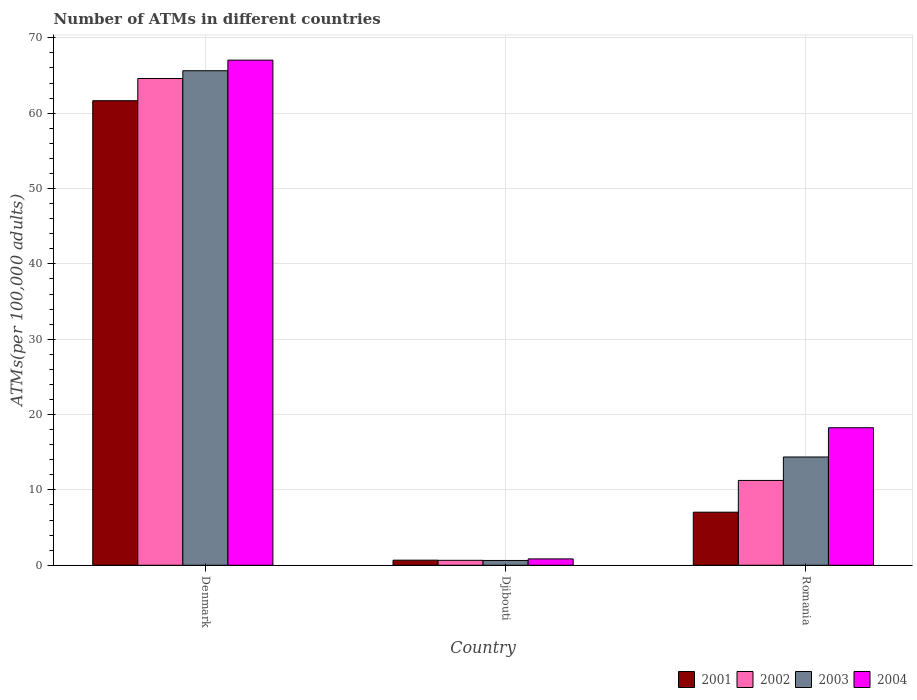How many different coloured bars are there?
Ensure brevity in your answer.  4. How many groups of bars are there?
Give a very brief answer. 3. Are the number of bars per tick equal to the number of legend labels?
Offer a terse response. Yes. Are the number of bars on each tick of the X-axis equal?
Your answer should be very brief. Yes. How many bars are there on the 2nd tick from the left?
Provide a succinct answer. 4. What is the label of the 2nd group of bars from the left?
Your answer should be very brief. Djibouti. In how many cases, is the number of bars for a given country not equal to the number of legend labels?
Your answer should be very brief. 0. What is the number of ATMs in 2002 in Romania?
Provide a short and direct response. 11.26. Across all countries, what is the maximum number of ATMs in 2001?
Your response must be concise. 61.66. Across all countries, what is the minimum number of ATMs in 2004?
Keep it short and to the point. 0.84. In which country was the number of ATMs in 2004 maximum?
Make the answer very short. Denmark. In which country was the number of ATMs in 2004 minimum?
Offer a very short reply. Djibouti. What is the total number of ATMs in 2003 in the graph?
Ensure brevity in your answer.  80.65. What is the difference between the number of ATMs in 2003 in Denmark and that in Djibouti?
Your answer should be very brief. 65. What is the difference between the number of ATMs in 2003 in Romania and the number of ATMs in 2002 in Denmark?
Provide a short and direct response. -50.24. What is the average number of ATMs in 2002 per country?
Make the answer very short. 25.51. What is the difference between the number of ATMs of/in 2002 and number of ATMs of/in 2001 in Denmark?
Offer a terse response. 2.95. What is the ratio of the number of ATMs in 2003 in Denmark to that in Romania?
Ensure brevity in your answer.  4.57. Is the number of ATMs in 2004 in Denmark less than that in Romania?
Provide a short and direct response. No. Is the difference between the number of ATMs in 2002 in Denmark and Romania greater than the difference between the number of ATMs in 2001 in Denmark and Romania?
Provide a short and direct response. No. What is the difference between the highest and the second highest number of ATMs in 2003?
Make the answer very short. -65. What is the difference between the highest and the lowest number of ATMs in 2002?
Ensure brevity in your answer.  63.95. In how many countries, is the number of ATMs in 2002 greater than the average number of ATMs in 2002 taken over all countries?
Give a very brief answer. 1. Is the sum of the number of ATMs in 2003 in Denmark and Romania greater than the maximum number of ATMs in 2004 across all countries?
Your answer should be compact. Yes. What does the 4th bar from the left in Djibouti represents?
Ensure brevity in your answer.  2004. Is it the case that in every country, the sum of the number of ATMs in 2001 and number of ATMs in 2003 is greater than the number of ATMs in 2004?
Offer a very short reply. Yes. What is the difference between two consecutive major ticks on the Y-axis?
Provide a succinct answer. 10. Are the values on the major ticks of Y-axis written in scientific E-notation?
Ensure brevity in your answer.  No. Does the graph contain any zero values?
Your answer should be very brief. No. Where does the legend appear in the graph?
Ensure brevity in your answer.  Bottom right. How are the legend labels stacked?
Provide a succinct answer. Horizontal. What is the title of the graph?
Provide a short and direct response. Number of ATMs in different countries. What is the label or title of the X-axis?
Offer a very short reply. Country. What is the label or title of the Y-axis?
Provide a succinct answer. ATMs(per 100,0 adults). What is the ATMs(per 100,000 adults) of 2001 in Denmark?
Keep it short and to the point. 61.66. What is the ATMs(per 100,000 adults) in 2002 in Denmark?
Give a very brief answer. 64.61. What is the ATMs(per 100,000 adults) in 2003 in Denmark?
Offer a very short reply. 65.64. What is the ATMs(per 100,000 adults) in 2004 in Denmark?
Keep it short and to the point. 67.04. What is the ATMs(per 100,000 adults) in 2001 in Djibouti?
Keep it short and to the point. 0.68. What is the ATMs(per 100,000 adults) in 2002 in Djibouti?
Your answer should be very brief. 0.66. What is the ATMs(per 100,000 adults) of 2003 in Djibouti?
Your answer should be compact. 0.64. What is the ATMs(per 100,000 adults) of 2004 in Djibouti?
Provide a succinct answer. 0.84. What is the ATMs(per 100,000 adults) in 2001 in Romania?
Your answer should be compact. 7.04. What is the ATMs(per 100,000 adults) in 2002 in Romania?
Your response must be concise. 11.26. What is the ATMs(per 100,000 adults) in 2003 in Romania?
Provide a short and direct response. 14.37. What is the ATMs(per 100,000 adults) in 2004 in Romania?
Ensure brevity in your answer.  18.26. Across all countries, what is the maximum ATMs(per 100,000 adults) of 2001?
Your answer should be very brief. 61.66. Across all countries, what is the maximum ATMs(per 100,000 adults) of 2002?
Ensure brevity in your answer.  64.61. Across all countries, what is the maximum ATMs(per 100,000 adults) of 2003?
Your answer should be very brief. 65.64. Across all countries, what is the maximum ATMs(per 100,000 adults) of 2004?
Give a very brief answer. 67.04. Across all countries, what is the minimum ATMs(per 100,000 adults) of 2001?
Your response must be concise. 0.68. Across all countries, what is the minimum ATMs(per 100,000 adults) in 2002?
Provide a succinct answer. 0.66. Across all countries, what is the minimum ATMs(per 100,000 adults) in 2003?
Your response must be concise. 0.64. Across all countries, what is the minimum ATMs(per 100,000 adults) in 2004?
Give a very brief answer. 0.84. What is the total ATMs(per 100,000 adults) in 2001 in the graph?
Offer a terse response. 69.38. What is the total ATMs(per 100,000 adults) of 2002 in the graph?
Your response must be concise. 76.52. What is the total ATMs(per 100,000 adults) of 2003 in the graph?
Provide a succinct answer. 80.65. What is the total ATMs(per 100,000 adults) of 2004 in the graph?
Your answer should be compact. 86.14. What is the difference between the ATMs(per 100,000 adults) of 2001 in Denmark and that in Djibouti?
Provide a succinct answer. 60.98. What is the difference between the ATMs(per 100,000 adults) of 2002 in Denmark and that in Djibouti?
Keep it short and to the point. 63.95. What is the difference between the ATMs(per 100,000 adults) in 2003 in Denmark and that in Djibouti?
Provide a short and direct response. 65. What is the difference between the ATMs(per 100,000 adults) in 2004 in Denmark and that in Djibouti?
Make the answer very short. 66.2. What is the difference between the ATMs(per 100,000 adults) in 2001 in Denmark and that in Romania?
Give a very brief answer. 54.61. What is the difference between the ATMs(per 100,000 adults) in 2002 in Denmark and that in Romania?
Ensure brevity in your answer.  53.35. What is the difference between the ATMs(per 100,000 adults) in 2003 in Denmark and that in Romania?
Your response must be concise. 51.27. What is the difference between the ATMs(per 100,000 adults) of 2004 in Denmark and that in Romania?
Provide a succinct answer. 48.79. What is the difference between the ATMs(per 100,000 adults) of 2001 in Djibouti and that in Romania?
Your answer should be very brief. -6.37. What is the difference between the ATMs(per 100,000 adults) of 2002 in Djibouti and that in Romania?
Your response must be concise. -10.6. What is the difference between the ATMs(per 100,000 adults) of 2003 in Djibouti and that in Romania?
Make the answer very short. -13.73. What is the difference between the ATMs(per 100,000 adults) in 2004 in Djibouti and that in Romania?
Make the answer very short. -17.41. What is the difference between the ATMs(per 100,000 adults) in 2001 in Denmark and the ATMs(per 100,000 adults) in 2002 in Djibouti?
Offer a very short reply. 61. What is the difference between the ATMs(per 100,000 adults) in 2001 in Denmark and the ATMs(per 100,000 adults) in 2003 in Djibouti?
Give a very brief answer. 61.02. What is the difference between the ATMs(per 100,000 adults) in 2001 in Denmark and the ATMs(per 100,000 adults) in 2004 in Djibouti?
Provide a succinct answer. 60.81. What is the difference between the ATMs(per 100,000 adults) in 2002 in Denmark and the ATMs(per 100,000 adults) in 2003 in Djibouti?
Keep it short and to the point. 63.97. What is the difference between the ATMs(per 100,000 adults) of 2002 in Denmark and the ATMs(per 100,000 adults) of 2004 in Djibouti?
Keep it short and to the point. 63.76. What is the difference between the ATMs(per 100,000 adults) of 2003 in Denmark and the ATMs(per 100,000 adults) of 2004 in Djibouti?
Keep it short and to the point. 64.79. What is the difference between the ATMs(per 100,000 adults) of 2001 in Denmark and the ATMs(per 100,000 adults) of 2002 in Romania?
Make the answer very short. 50.4. What is the difference between the ATMs(per 100,000 adults) in 2001 in Denmark and the ATMs(per 100,000 adults) in 2003 in Romania?
Make the answer very short. 47.29. What is the difference between the ATMs(per 100,000 adults) in 2001 in Denmark and the ATMs(per 100,000 adults) in 2004 in Romania?
Keep it short and to the point. 43.4. What is the difference between the ATMs(per 100,000 adults) in 2002 in Denmark and the ATMs(per 100,000 adults) in 2003 in Romania?
Your response must be concise. 50.24. What is the difference between the ATMs(per 100,000 adults) of 2002 in Denmark and the ATMs(per 100,000 adults) of 2004 in Romania?
Your answer should be very brief. 46.35. What is the difference between the ATMs(per 100,000 adults) in 2003 in Denmark and the ATMs(per 100,000 adults) in 2004 in Romania?
Ensure brevity in your answer.  47.38. What is the difference between the ATMs(per 100,000 adults) in 2001 in Djibouti and the ATMs(per 100,000 adults) in 2002 in Romania?
Your response must be concise. -10.58. What is the difference between the ATMs(per 100,000 adults) of 2001 in Djibouti and the ATMs(per 100,000 adults) of 2003 in Romania?
Keep it short and to the point. -13.69. What is the difference between the ATMs(per 100,000 adults) of 2001 in Djibouti and the ATMs(per 100,000 adults) of 2004 in Romania?
Ensure brevity in your answer.  -17.58. What is the difference between the ATMs(per 100,000 adults) in 2002 in Djibouti and the ATMs(per 100,000 adults) in 2003 in Romania?
Provide a short and direct response. -13.71. What is the difference between the ATMs(per 100,000 adults) of 2002 in Djibouti and the ATMs(per 100,000 adults) of 2004 in Romania?
Provide a short and direct response. -17.6. What is the difference between the ATMs(per 100,000 adults) of 2003 in Djibouti and the ATMs(per 100,000 adults) of 2004 in Romania?
Make the answer very short. -17.62. What is the average ATMs(per 100,000 adults) of 2001 per country?
Offer a terse response. 23.13. What is the average ATMs(per 100,000 adults) of 2002 per country?
Keep it short and to the point. 25.51. What is the average ATMs(per 100,000 adults) of 2003 per country?
Keep it short and to the point. 26.88. What is the average ATMs(per 100,000 adults) of 2004 per country?
Give a very brief answer. 28.71. What is the difference between the ATMs(per 100,000 adults) in 2001 and ATMs(per 100,000 adults) in 2002 in Denmark?
Provide a succinct answer. -2.95. What is the difference between the ATMs(per 100,000 adults) in 2001 and ATMs(per 100,000 adults) in 2003 in Denmark?
Ensure brevity in your answer.  -3.98. What is the difference between the ATMs(per 100,000 adults) of 2001 and ATMs(per 100,000 adults) of 2004 in Denmark?
Provide a succinct answer. -5.39. What is the difference between the ATMs(per 100,000 adults) in 2002 and ATMs(per 100,000 adults) in 2003 in Denmark?
Make the answer very short. -1.03. What is the difference between the ATMs(per 100,000 adults) in 2002 and ATMs(per 100,000 adults) in 2004 in Denmark?
Ensure brevity in your answer.  -2.44. What is the difference between the ATMs(per 100,000 adults) of 2003 and ATMs(per 100,000 adults) of 2004 in Denmark?
Give a very brief answer. -1.41. What is the difference between the ATMs(per 100,000 adults) in 2001 and ATMs(per 100,000 adults) in 2002 in Djibouti?
Make the answer very short. 0.02. What is the difference between the ATMs(per 100,000 adults) of 2001 and ATMs(per 100,000 adults) of 2003 in Djibouti?
Offer a terse response. 0.04. What is the difference between the ATMs(per 100,000 adults) in 2001 and ATMs(per 100,000 adults) in 2004 in Djibouti?
Keep it short and to the point. -0.17. What is the difference between the ATMs(per 100,000 adults) of 2002 and ATMs(per 100,000 adults) of 2003 in Djibouti?
Offer a very short reply. 0.02. What is the difference between the ATMs(per 100,000 adults) in 2002 and ATMs(per 100,000 adults) in 2004 in Djibouti?
Keep it short and to the point. -0.19. What is the difference between the ATMs(per 100,000 adults) in 2003 and ATMs(per 100,000 adults) in 2004 in Djibouti?
Make the answer very short. -0.21. What is the difference between the ATMs(per 100,000 adults) in 2001 and ATMs(per 100,000 adults) in 2002 in Romania?
Your answer should be compact. -4.21. What is the difference between the ATMs(per 100,000 adults) of 2001 and ATMs(per 100,000 adults) of 2003 in Romania?
Your answer should be compact. -7.32. What is the difference between the ATMs(per 100,000 adults) in 2001 and ATMs(per 100,000 adults) in 2004 in Romania?
Your answer should be very brief. -11.21. What is the difference between the ATMs(per 100,000 adults) in 2002 and ATMs(per 100,000 adults) in 2003 in Romania?
Make the answer very short. -3.11. What is the difference between the ATMs(per 100,000 adults) in 2002 and ATMs(per 100,000 adults) in 2004 in Romania?
Your answer should be compact. -7. What is the difference between the ATMs(per 100,000 adults) of 2003 and ATMs(per 100,000 adults) of 2004 in Romania?
Your answer should be compact. -3.89. What is the ratio of the ATMs(per 100,000 adults) of 2001 in Denmark to that in Djibouti?
Your answer should be very brief. 91.18. What is the ratio of the ATMs(per 100,000 adults) of 2002 in Denmark to that in Djibouti?
Provide a succinct answer. 98.45. What is the ratio of the ATMs(per 100,000 adults) of 2003 in Denmark to that in Djibouti?
Offer a terse response. 102.88. What is the ratio of the ATMs(per 100,000 adults) of 2004 in Denmark to that in Djibouti?
Keep it short and to the point. 79.46. What is the ratio of the ATMs(per 100,000 adults) in 2001 in Denmark to that in Romania?
Your answer should be compact. 8.75. What is the ratio of the ATMs(per 100,000 adults) of 2002 in Denmark to that in Romania?
Make the answer very short. 5.74. What is the ratio of the ATMs(per 100,000 adults) in 2003 in Denmark to that in Romania?
Keep it short and to the point. 4.57. What is the ratio of the ATMs(per 100,000 adults) of 2004 in Denmark to that in Romania?
Ensure brevity in your answer.  3.67. What is the ratio of the ATMs(per 100,000 adults) of 2001 in Djibouti to that in Romania?
Provide a short and direct response. 0.1. What is the ratio of the ATMs(per 100,000 adults) of 2002 in Djibouti to that in Romania?
Provide a short and direct response. 0.06. What is the ratio of the ATMs(per 100,000 adults) of 2003 in Djibouti to that in Romania?
Your response must be concise. 0.04. What is the ratio of the ATMs(per 100,000 adults) of 2004 in Djibouti to that in Romania?
Provide a short and direct response. 0.05. What is the difference between the highest and the second highest ATMs(per 100,000 adults) of 2001?
Provide a succinct answer. 54.61. What is the difference between the highest and the second highest ATMs(per 100,000 adults) of 2002?
Offer a terse response. 53.35. What is the difference between the highest and the second highest ATMs(per 100,000 adults) in 2003?
Offer a terse response. 51.27. What is the difference between the highest and the second highest ATMs(per 100,000 adults) of 2004?
Your answer should be very brief. 48.79. What is the difference between the highest and the lowest ATMs(per 100,000 adults) in 2001?
Offer a terse response. 60.98. What is the difference between the highest and the lowest ATMs(per 100,000 adults) in 2002?
Keep it short and to the point. 63.95. What is the difference between the highest and the lowest ATMs(per 100,000 adults) in 2003?
Ensure brevity in your answer.  65. What is the difference between the highest and the lowest ATMs(per 100,000 adults) of 2004?
Provide a short and direct response. 66.2. 